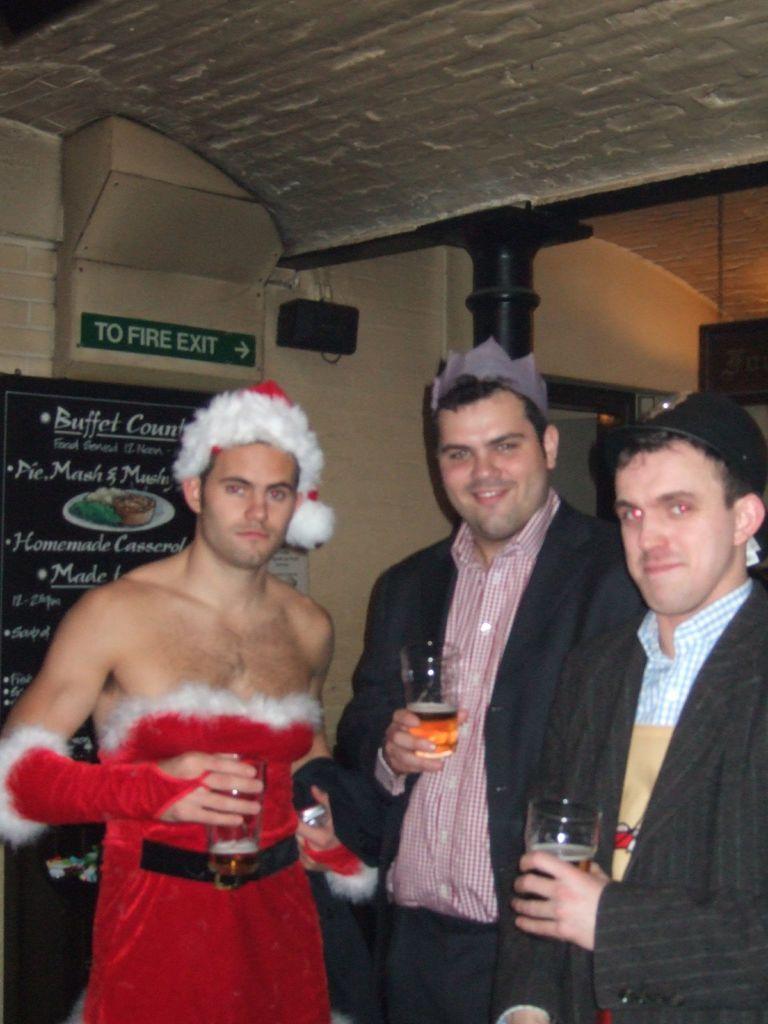Please provide a concise description of this image. In the foreground of this image, there are two men wearing suits and a man wearing female dress which is in red and white color. They are holding glasses. In the background, there is wall, ceiling, pillar, few boards and a black color object on the wall. 